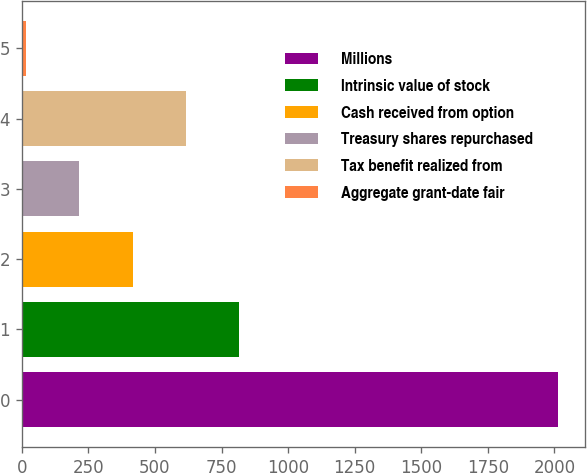Convert chart. <chart><loc_0><loc_0><loc_500><loc_500><bar_chart><fcel>Millions<fcel>Intrinsic value of stock<fcel>Cash received from option<fcel>Treasury shares repurchased<fcel>Tax benefit realized from<fcel>Aggregate grant-date fair<nl><fcel>2014<fcel>815.8<fcel>416.4<fcel>216.7<fcel>616.1<fcel>17<nl></chart> 